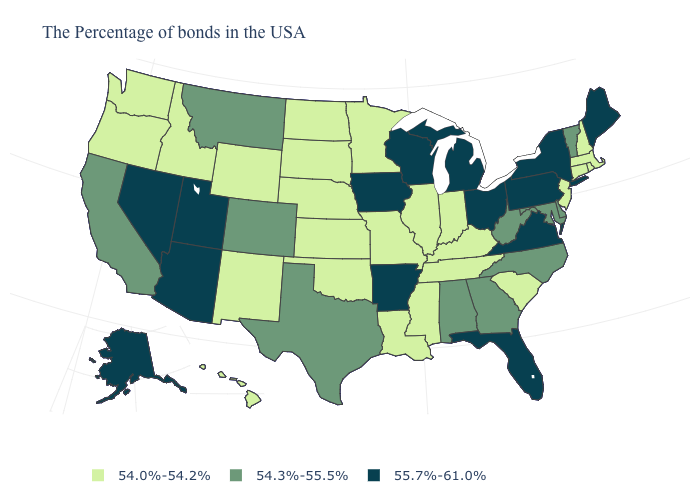Does the map have missing data?
Write a very short answer. No. What is the value of Hawaii?
Short answer required. 54.0%-54.2%. What is the value of Hawaii?
Be succinct. 54.0%-54.2%. Name the states that have a value in the range 54.3%-55.5%?
Answer briefly. Vermont, Delaware, Maryland, North Carolina, West Virginia, Georgia, Alabama, Texas, Colorado, Montana, California. Does the map have missing data?
Short answer required. No. Among the states that border Arizona , which have the highest value?
Give a very brief answer. Utah, Nevada. Does Wisconsin have the lowest value in the MidWest?
Quick response, please. No. Name the states that have a value in the range 55.7%-61.0%?
Short answer required. Maine, New York, Pennsylvania, Virginia, Ohio, Florida, Michigan, Wisconsin, Arkansas, Iowa, Utah, Arizona, Nevada, Alaska. Among the states that border Nevada , which have the lowest value?
Give a very brief answer. Idaho, Oregon. Which states have the highest value in the USA?
Quick response, please. Maine, New York, Pennsylvania, Virginia, Ohio, Florida, Michigan, Wisconsin, Arkansas, Iowa, Utah, Arizona, Nevada, Alaska. What is the highest value in states that border Ohio?
Concise answer only. 55.7%-61.0%. Name the states that have a value in the range 54.3%-55.5%?
Quick response, please. Vermont, Delaware, Maryland, North Carolina, West Virginia, Georgia, Alabama, Texas, Colorado, Montana, California. Does the map have missing data?
Be succinct. No. What is the value of Arkansas?
Concise answer only. 55.7%-61.0%. Does Hawaii have the same value as Michigan?
Short answer required. No. 